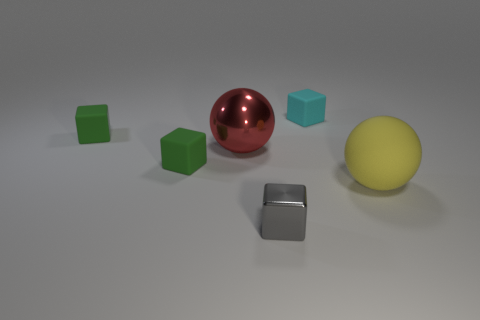What positions are the red and yellow spheres in relative to the grey cube? The red sphere is to the left of the grey cube and slightly behind it, while the yellow sphere is to the right and slightly in front of the grey cube. Is there any pattern in how the objects are arranged? Yes, there is a discernible pattern where the three cubes on the left are arranged in increasing size from left to right, and the spheres on the right are also placed by size with the smaller one being closer to the cubes. 